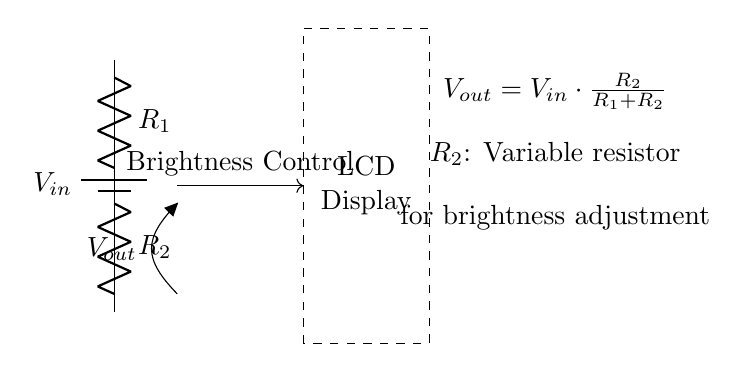What is the input voltage of this circuit? The input voltage \( V_{in} \) is designated as the potential from the battery at the top of the circuit. It is not specified in the circuit, but typically it is a standard voltage value applied to the circuit for functionality.
Answer: \( V_{in} \) What is the purpose of resistor \( R_2 \)? Resistor \( R_2 \) is labeled as a variable resistor, which indicates that it is used to adjust the output voltage \( V_{out} \). By changing its resistance, the amount of voltage available to the display can be modified, thereby controlling the brightness.
Answer: Adjust brightness What is the formula for the output voltage? The output voltage \( V_{out} \) is calculated using the formula given in the circuit diagram, which shows that it is dependent on both resistors in the voltage divider configuration; specifically, it states that \( V_{out} = V_{in} \cdot \frac{R_2}{R_1 + R_2} \).
Answer: \( V_{out} = V_{in} \cdot \frac{R_2}{R_1 + R_2} \) How does increasing \( R_2 \) affect brightness? Increasing \( R_2 \) in the voltage divider circuit causes \( V_{out} \) to increase, resulting in a higher voltage being supplied to the LCD display. This increase in voltage leads to a brighter display. Therefore, the brightness control works by adjusting \( R_2 \).
Answer: Brightness increases What type of circuit is this? This is a voltage divider circuit, which is specifically used for adjusting output voltage levels. Such circuits are common in applications like brightness control for displays by providing a lower voltage to the load (in this case, the LCD display).
Answer: Voltage divider What is the role of the battery in this circuit? The battery serves as the power source, providing the input voltage \( V_{in} \) needed for the circuit to operate. Without the battery supplying power, the circuit would not function, as there would be no voltage to divide across the resistors.
Answer: Power source 